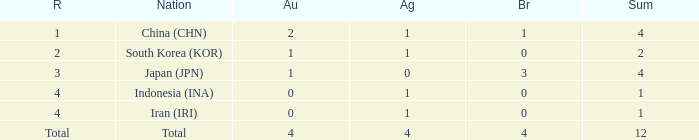How many silver medals for the nation with fewer than 1 golds and total less than 1? 0.0. 